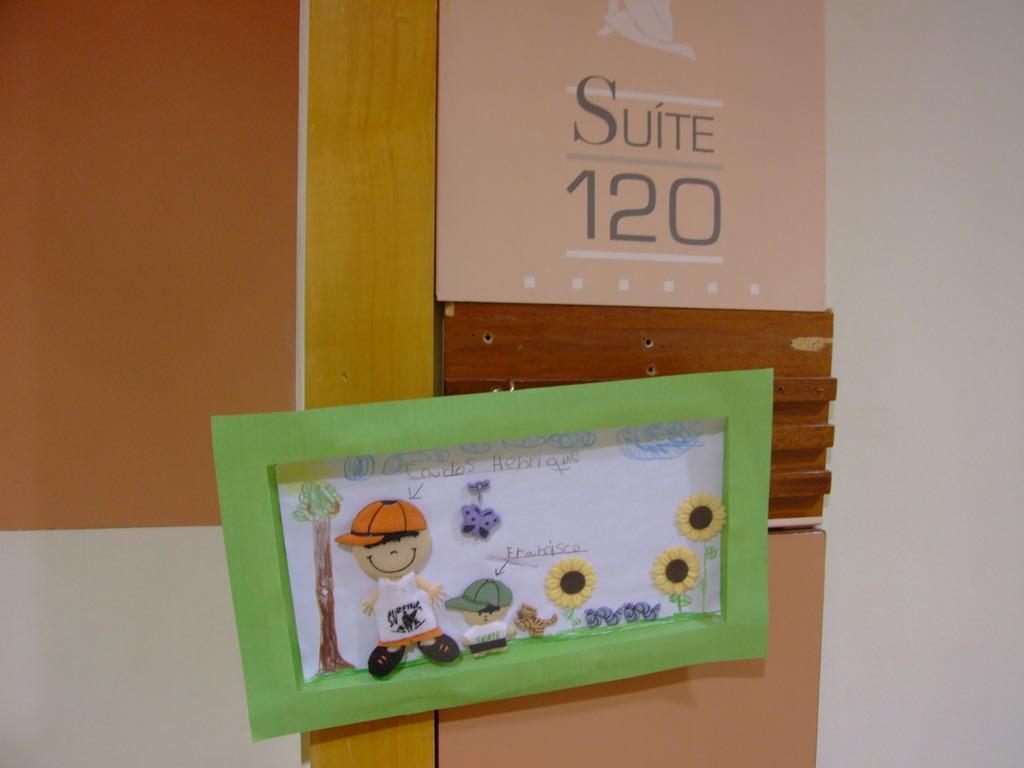Please provide a concise description of this image. In the center of this picture we can see the text and the drawings of flowers and a tree and we can see the drawings of the two persons and an animal on the paper with the frame. In the background we can see the text and numbers on the poster which seems to be attached to the wall and we can see some other objects. 